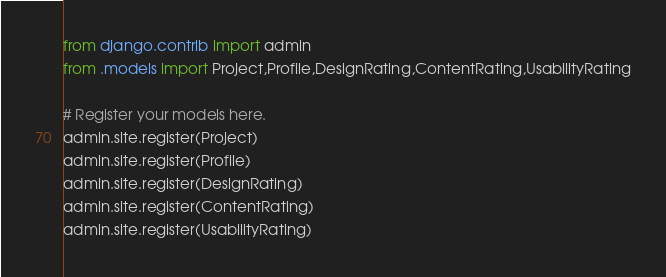<code> <loc_0><loc_0><loc_500><loc_500><_Python_>from django.contrib import admin
from .models import Project,Profile,DesignRating,ContentRating,UsabilityRating

# Register your models here.
admin.site.register(Project)
admin.site.register(Profile)
admin.site.register(DesignRating)
admin.site.register(ContentRating)
admin.site.register(UsabilityRating)
</code> 